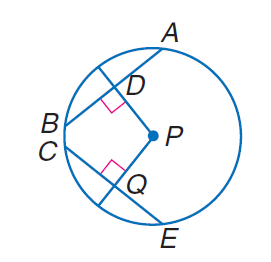Question: In \odot P, P D = 10, P Q = 10, and Q E = 20, find P E.
Choices:
A. 10
B. 20
C. 10 \sqrt { 5 }
D. 30
Answer with the letter. Answer: C 